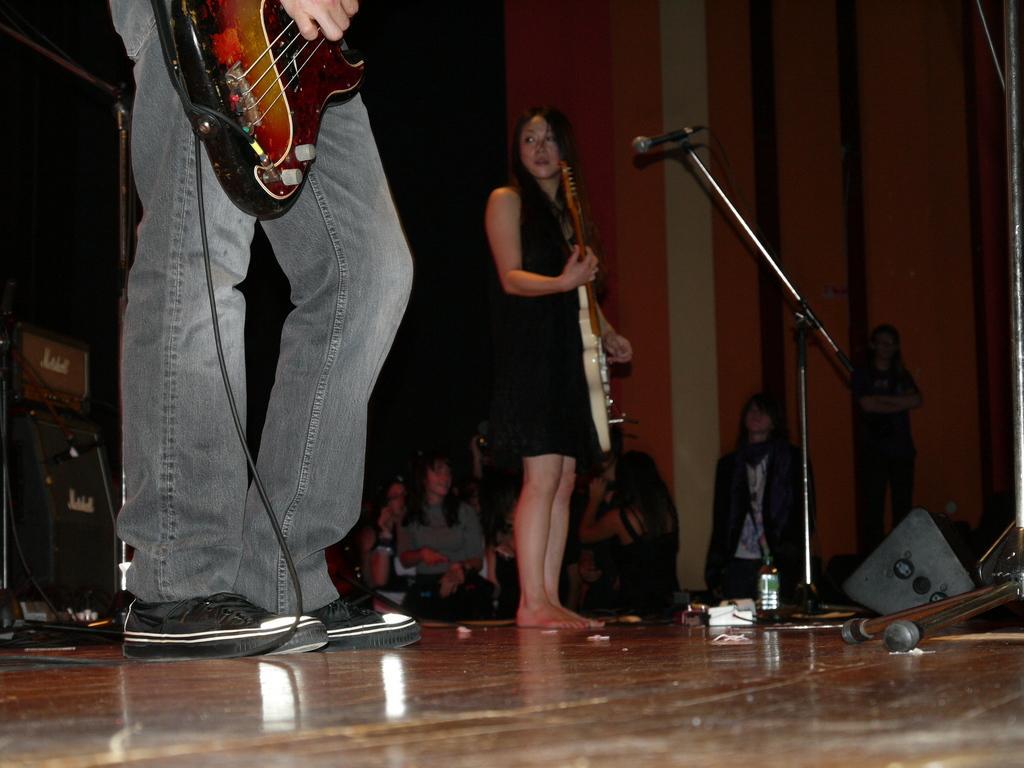Describe this image in one or two sentences. As we can see in the image there are few people over here and these two people are holding guitars in their hands. In front of her there is a mic. 